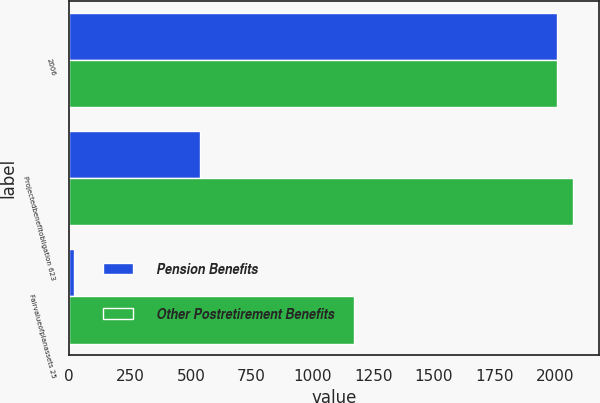Convert chart to OTSL. <chart><loc_0><loc_0><loc_500><loc_500><stacked_bar_chart><ecel><fcel>2006<fcel>Projectedbenefitobligation 623<fcel>Fairvalueofplanassets 25<nl><fcel>Pension Benefits<fcel>2005<fcel>538<fcel>19<nl><fcel>Other Postretirement Benefits<fcel>2006<fcel>2073<fcel>1172<nl></chart> 